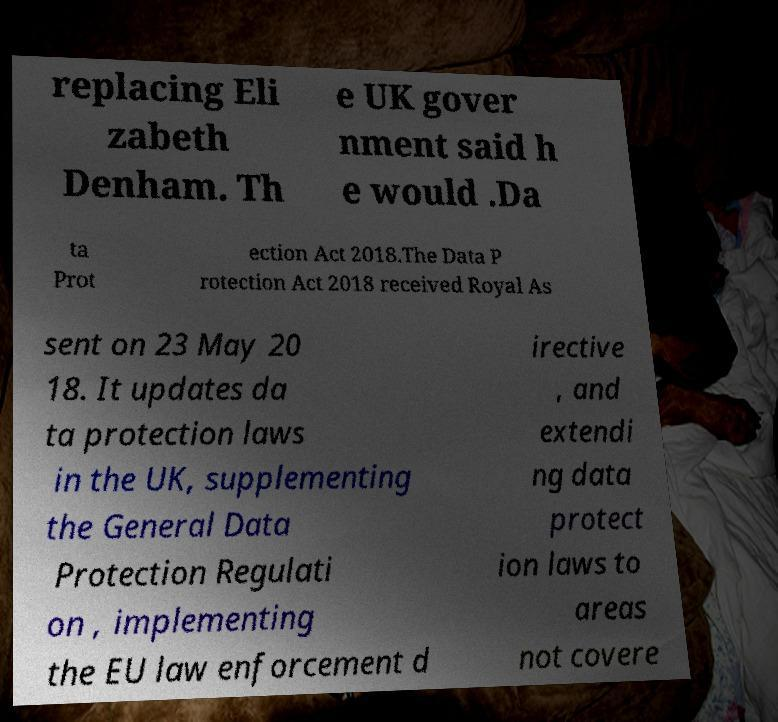Can you read and provide the text displayed in the image?This photo seems to have some interesting text. Can you extract and type it out for me? replacing Eli zabeth Denham. Th e UK gover nment said h e would .Da ta Prot ection Act 2018.The Data P rotection Act 2018 received Royal As sent on 23 May 20 18. It updates da ta protection laws in the UK, supplementing the General Data Protection Regulati on , implementing the EU law enforcement d irective , and extendi ng data protect ion laws to areas not covere 